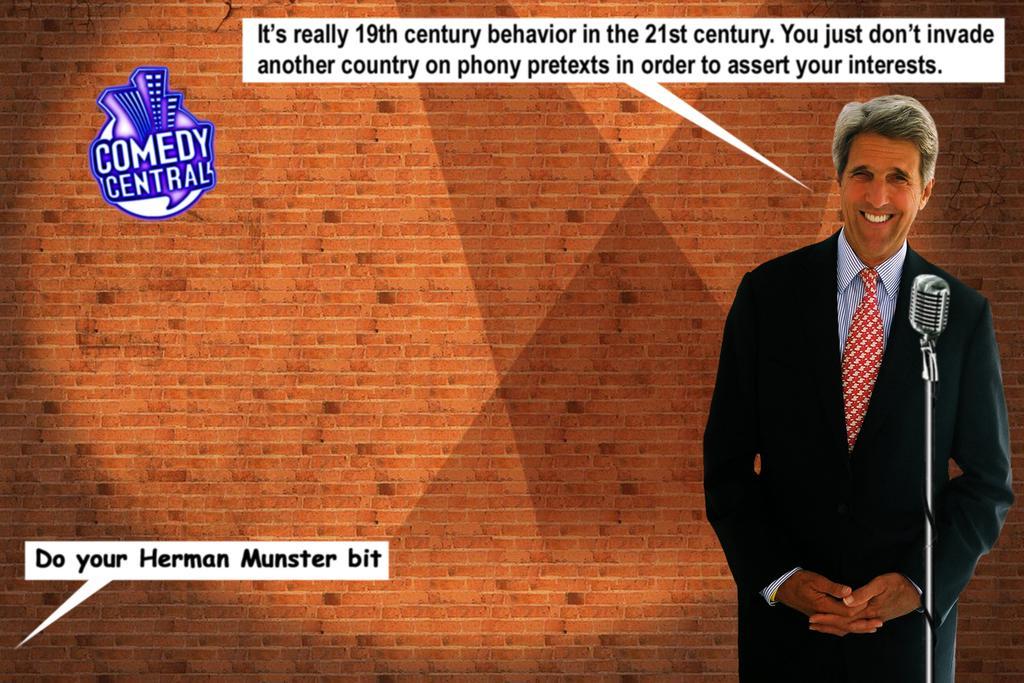Describe this image in one or two sentences. In this image I can see a person wearing shirt, tie, black blazer and black pant is standing and I can see a microphone in front of him. In the background I can see the wall which is made of bricks. 